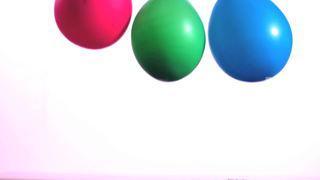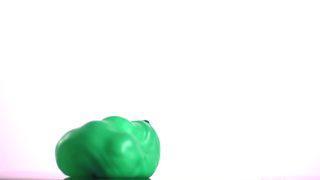The first image is the image on the left, the second image is the image on the right. Assess this claim about the two images: "One image includes a lumpy-looking green balloon, and the other image includes at least two balloons of different colors.". Correct or not? Answer yes or no. Yes. The first image is the image on the left, the second image is the image on the right. Considering the images on both sides, is "One of the balloons is bright pink." valid? Answer yes or no. Yes. 